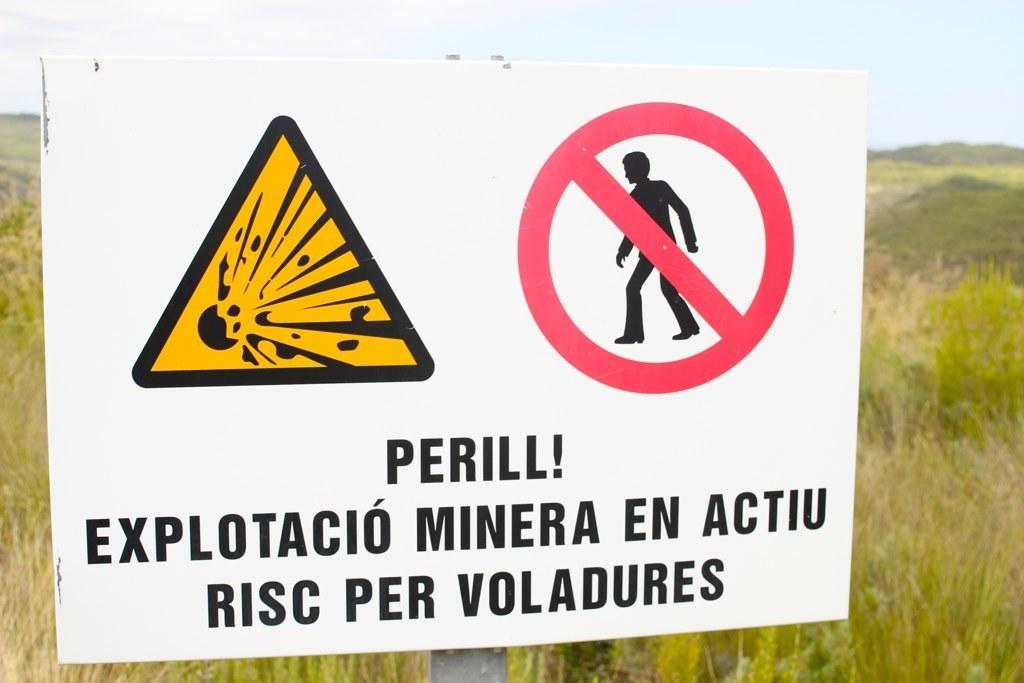In one or two sentences, can you explain what this image depicts? In the image in the center, we can see one sign board and we can see something written on it. In the background, we can see the sky, clouds, plants and grass. 